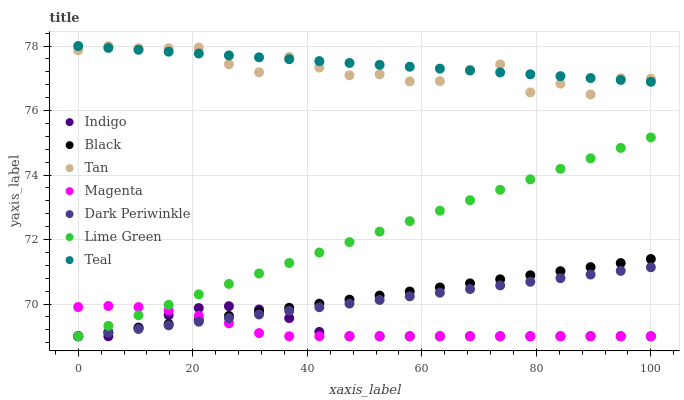Does Magenta have the minimum area under the curve?
Answer yes or no. Yes. Does Teal have the maximum area under the curve?
Answer yes or no. Yes. Does Dark Periwinkle have the minimum area under the curve?
Answer yes or no. No. Does Dark Periwinkle have the maximum area under the curve?
Answer yes or no. No. Is Dark Periwinkle the smoothest?
Answer yes or no. Yes. Is Tan the roughest?
Answer yes or no. Yes. Is Black the smoothest?
Answer yes or no. No. Is Black the roughest?
Answer yes or no. No. Does Indigo have the lowest value?
Answer yes or no. Yes. Does Teal have the lowest value?
Answer yes or no. No. Does Tan have the highest value?
Answer yes or no. Yes. Does Dark Periwinkle have the highest value?
Answer yes or no. No. Is Indigo less than Teal?
Answer yes or no. Yes. Is Teal greater than Magenta?
Answer yes or no. Yes. Does Tan intersect Teal?
Answer yes or no. Yes. Is Tan less than Teal?
Answer yes or no. No. Is Tan greater than Teal?
Answer yes or no. No. Does Indigo intersect Teal?
Answer yes or no. No. 